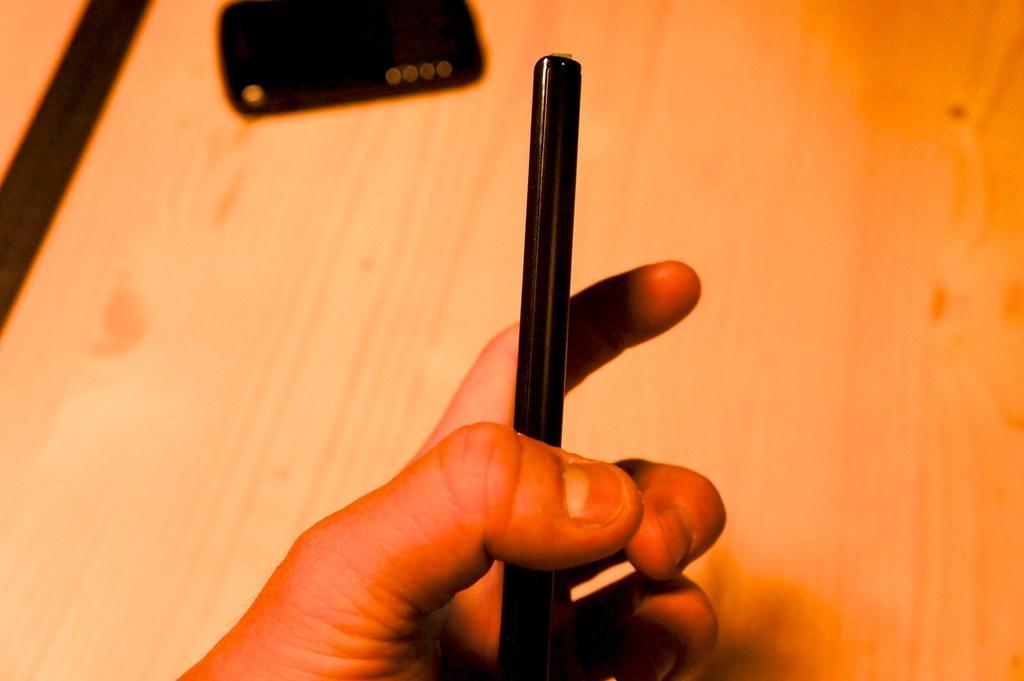Could you give a brief overview of what you see in this image? In the foreground of this image, it seems like a mobile holding by the hand of a person. In the background, there is a wooden surface on which there is a pouch like an object at the top. 